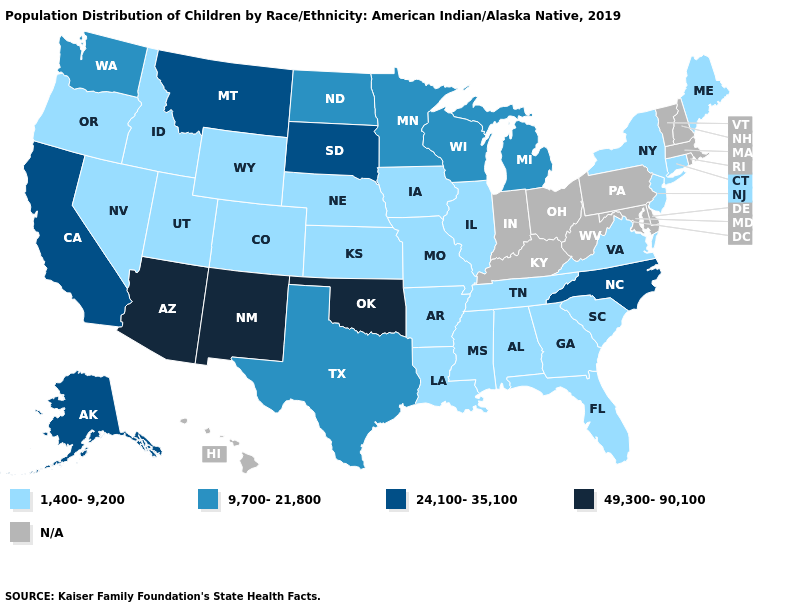Which states have the lowest value in the West?
Write a very short answer. Colorado, Idaho, Nevada, Oregon, Utah, Wyoming. Among the states that border Colorado , which have the highest value?
Write a very short answer. Arizona, New Mexico, Oklahoma. Does the first symbol in the legend represent the smallest category?
Write a very short answer. Yes. What is the value of New Jersey?
Quick response, please. 1,400-9,200. What is the lowest value in the South?
Keep it brief. 1,400-9,200. Name the states that have a value in the range N/A?
Short answer required. Delaware, Hawaii, Indiana, Kentucky, Maryland, Massachusetts, New Hampshire, Ohio, Pennsylvania, Rhode Island, Vermont, West Virginia. What is the value of Wyoming?
Write a very short answer. 1,400-9,200. Name the states that have a value in the range 9,700-21,800?
Keep it brief. Michigan, Minnesota, North Dakota, Texas, Washington, Wisconsin. Name the states that have a value in the range 1,400-9,200?
Answer briefly. Alabama, Arkansas, Colorado, Connecticut, Florida, Georgia, Idaho, Illinois, Iowa, Kansas, Louisiana, Maine, Mississippi, Missouri, Nebraska, Nevada, New Jersey, New York, Oregon, South Carolina, Tennessee, Utah, Virginia, Wyoming. What is the value of Nebraska?
Concise answer only. 1,400-9,200. What is the value of Vermont?
Concise answer only. N/A. Does the map have missing data?
Write a very short answer. Yes. Does Alaska have the highest value in the USA?
Quick response, please. No. Name the states that have a value in the range 49,300-90,100?
Answer briefly. Arizona, New Mexico, Oklahoma. Is the legend a continuous bar?
Answer briefly. No. 